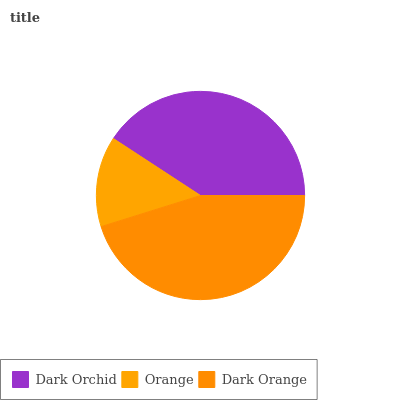Is Orange the minimum?
Answer yes or no. Yes. Is Dark Orange the maximum?
Answer yes or no. Yes. Is Dark Orange the minimum?
Answer yes or no. No. Is Orange the maximum?
Answer yes or no. No. Is Dark Orange greater than Orange?
Answer yes or no. Yes. Is Orange less than Dark Orange?
Answer yes or no. Yes. Is Orange greater than Dark Orange?
Answer yes or no. No. Is Dark Orange less than Orange?
Answer yes or no. No. Is Dark Orchid the high median?
Answer yes or no. Yes. Is Dark Orchid the low median?
Answer yes or no. Yes. Is Dark Orange the high median?
Answer yes or no. No. Is Dark Orange the low median?
Answer yes or no. No. 